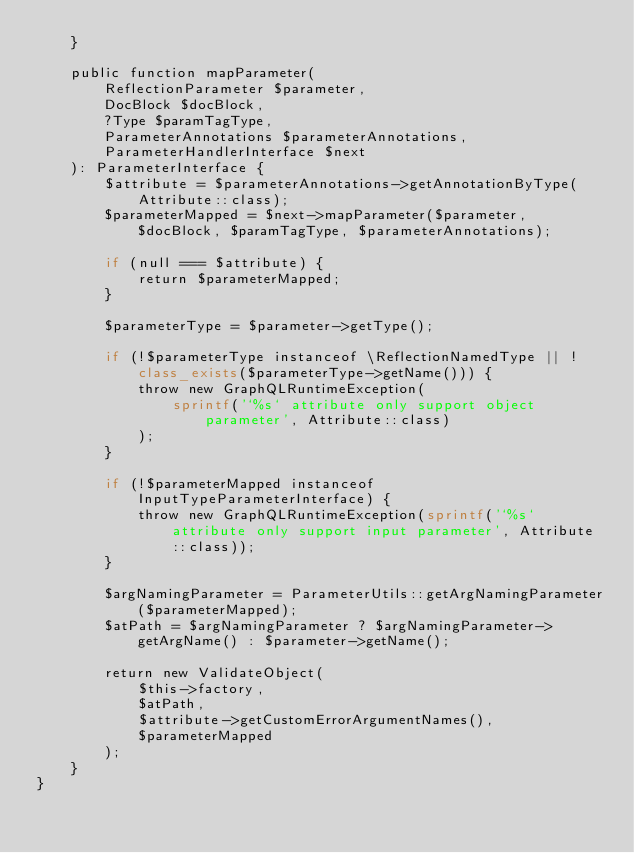<code> <loc_0><loc_0><loc_500><loc_500><_PHP_>    }

    public function mapParameter(
        ReflectionParameter $parameter,
        DocBlock $docBlock,
        ?Type $paramTagType,
        ParameterAnnotations $parameterAnnotations,
        ParameterHandlerInterface $next
    ): ParameterInterface {
        $attribute = $parameterAnnotations->getAnnotationByType(Attribute::class);
        $parameterMapped = $next->mapParameter($parameter, $docBlock, $paramTagType, $parameterAnnotations);

        if (null === $attribute) {
            return $parameterMapped;
        }

        $parameterType = $parameter->getType();

        if (!$parameterType instanceof \ReflectionNamedType || !class_exists($parameterType->getName())) {
            throw new GraphQLRuntimeException(
                sprintf('`%s` attribute only support object parameter', Attribute::class)
            );
        }

        if (!$parameterMapped instanceof InputTypeParameterInterface) {
            throw new GraphQLRuntimeException(sprintf('`%s` attribute only support input parameter', Attribute::class));
        }

        $argNamingParameter = ParameterUtils::getArgNamingParameter($parameterMapped);
        $atPath = $argNamingParameter ? $argNamingParameter->getArgName() : $parameter->getName();

        return new ValidateObject(
            $this->factory,
            $atPath,
            $attribute->getCustomErrorArgumentNames(),
            $parameterMapped
        );
    }
}
</code> 